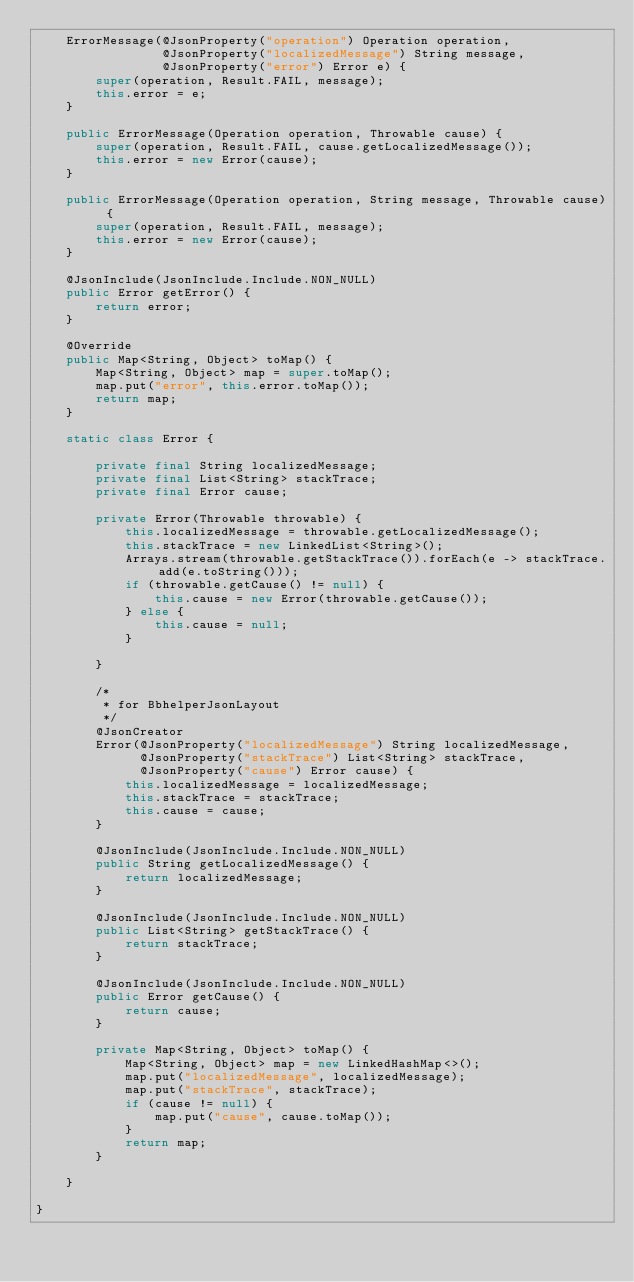<code> <loc_0><loc_0><loc_500><loc_500><_Java_>    ErrorMessage(@JsonProperty("operation") Operation operation,
                 @JsonProperty("localizedMessage") String message,
                 @JsonProperty("error") Error e) {
        super(operation, Result.FAIL, message);
        this.error = e;
    }

    public ErrorMessage(Operation operation, Throwable cause) {
        super(operation, Result.FAIL, cause.getLocalizedMessage());
        this.error = new Error(cause);
    }

    public ErrorMessage(Operation operation, String message, Throwable cause) {
        super(operation, Result.FAIL, message);
        this.error = new Error(cause);
    }

    @JsonInclude(JsonInclude.Include.NON_NULL)
    public Error getError() {
        return error;
    }

    @Override
    public Map<String, Object> toMap() {
        Map<String, Object> map = super.toMap();
        map.put("error", this.error.toMap());
        return map;
    }

    static class Error {

        private final String localizedMessage;
        private final List<String> stackTrace;
        private final Error cause;

        private Error(Throwable throwable) {
            this.localizedMessage = throwable.getLocalizedMessage();
            this.stackTrace = new LinkedList<String>();
            Arrays.stream(throwable.getStackTrace()).forEach(e -> stackTrace.add(e.toString()));
            if (throwable.getCause() != null) {
                this.cause = new Error(throwable.getCause());
            } else {
                this.cause = null;
            }

        }

        /*
         * for BbhelperJsonLayout
         */
        @JsonCreator
        Error(@JsonProperty("localizedMessage") String localizedMessage,
              @JsonProperty("stackTrace") List<String> stackTrace,
              @JsonProperty("cause") Error cause) {
            this.localizedMessage = localizedMessage;
            this.stackTrace = stackTrace;
            this.cause = cause;
        }

        @JsonInclude(JsonInclude.Include.NON_NULL)
        public String getLocalizedMessage() {
            return localizedMessage;
        }

        @JsonInclude(JsonInclude.Include.NON_NULL)
        public List<String> getStackTrace() {
            return stackTrace;
        }

        @JsonInclude(JsonInclude.Include.NON_NULL)
        public Error getCause() {
            return cause;
        }

        private Map<String, Object> toMap() {
            Map<String, Object> map = new LinkedHashMap<>();
            map.put("localizedMessage", localizedMessage);
            map.put("stackTrace", stackTrace);
            if (cause != null) {
                map.put("cause", cause.toMap());
            }
            return map;
        }

    }

}
</code> 